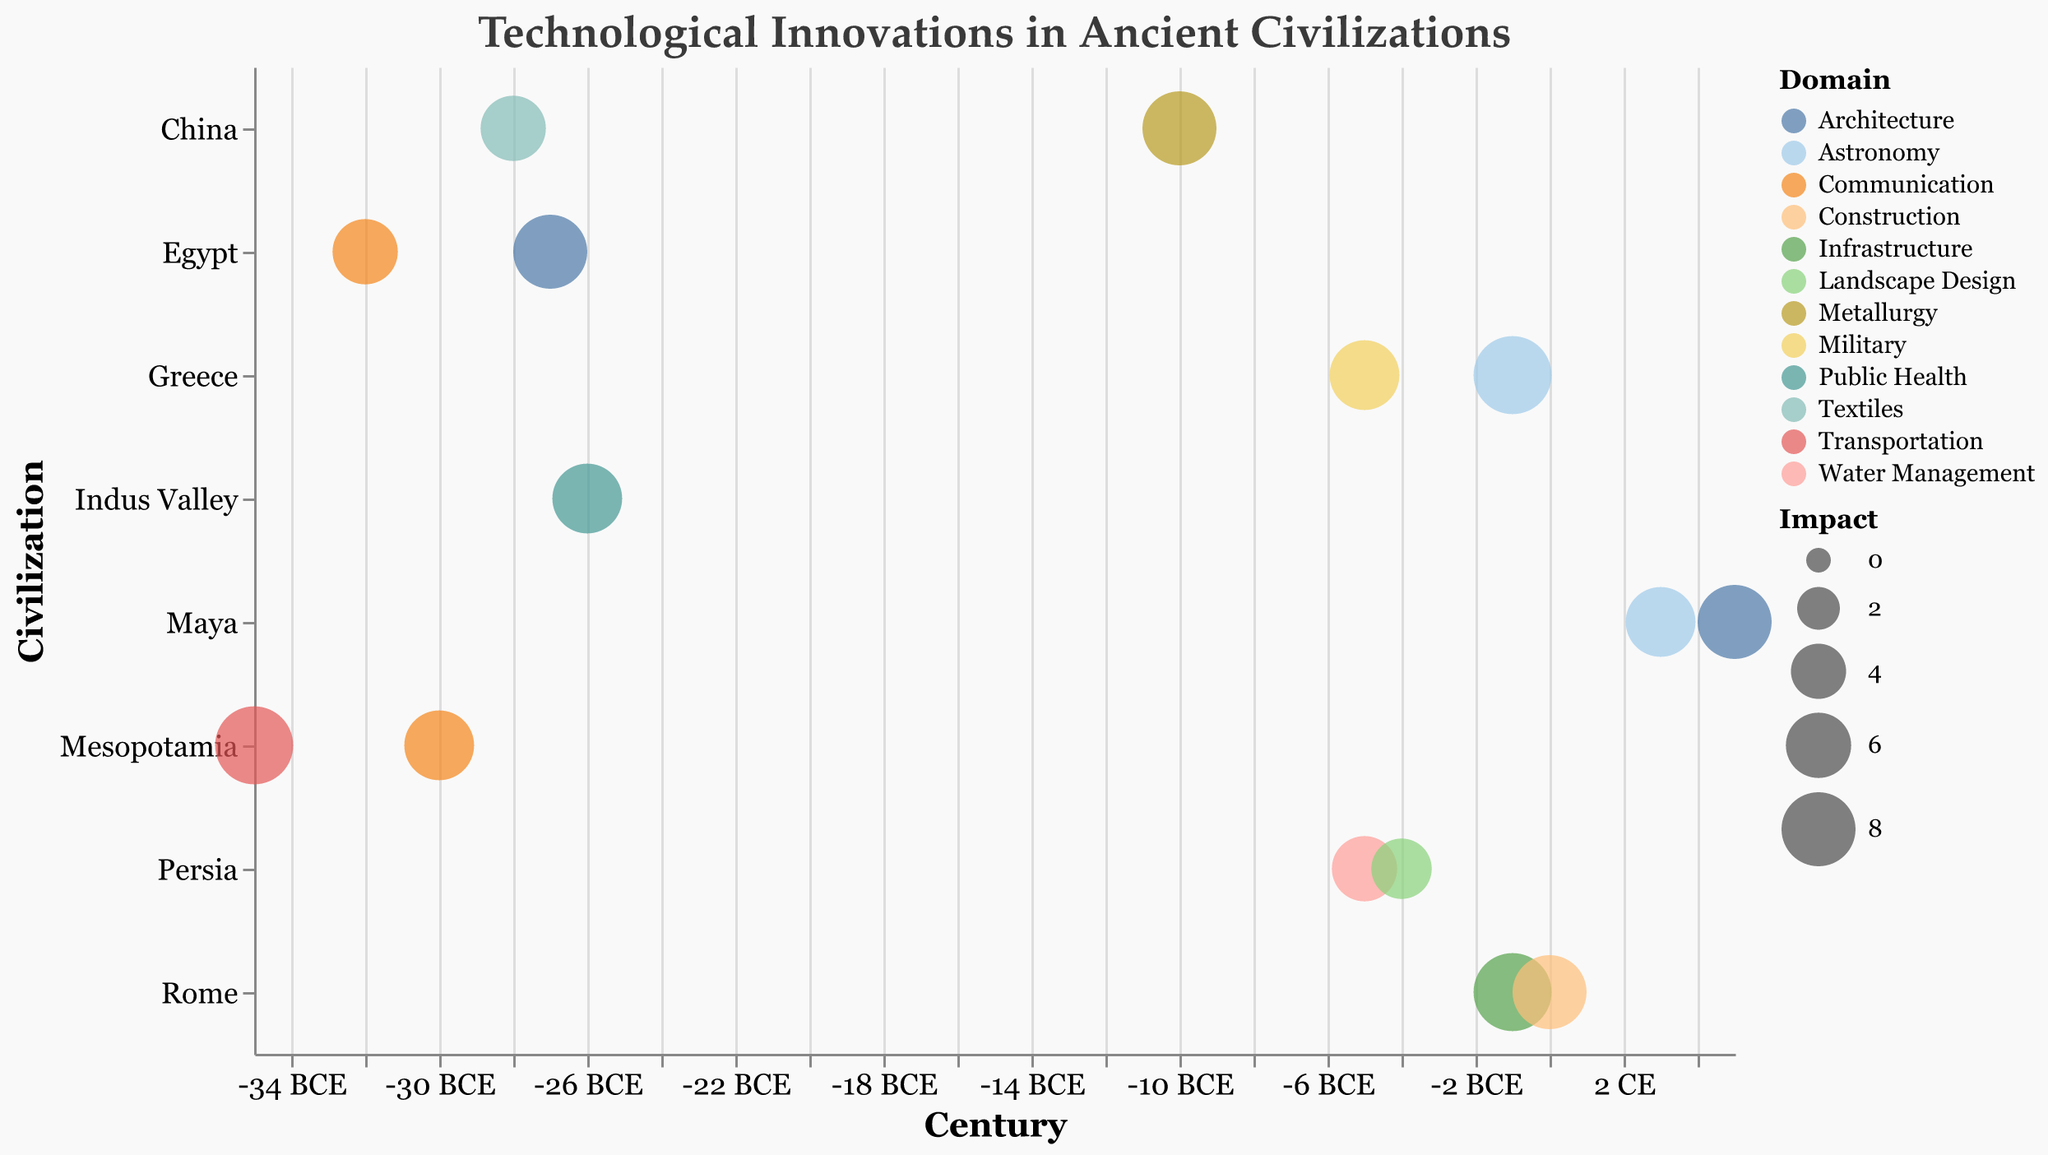What's the title of the chart? The title of the chart is displayed at the top and reads "Technological Innovations in Ancient Civilizations."
Answer: Technological Innovations in Ancient Civilizations How many innovations are depicted for the civilization of Greece? By counting the bubbles aligned with Greece on the y-axis, we see there are two innovations: "Antikythera Mechanism" and "Phalanx Warfare."
Answer: 2 Which innovation from Mesopotamia has the highest impact? By looking at the size of the bubbles for Mesopotamia, we find that the innovation "Wheel" has the largest bubble, indicating the highest impact of 9.
Answer: Wheel How does the impact of China's "Silk Weaving" compare to its "Cast Iron"? "Silk Weaving" has an impact of 6, while "Cast Iron" has an impact of 8. Therefore, "Cast Iron" has a higher impact than "Silk Weaving."
Answer: Cast Iron has higher impact Between which centuries do we see the most innovations in this chart? Observing the distribution of bubbles along the x-axis, most innovations appear between the 0 and -35 centuries. This indicates a rich period of technological advancement before the common era.
Answer: -35 to 0 centuries What is the century range of Persian innovations? Counting the bubbles belonging to Persia, the innovations "Qanat System" and "Paradise Gardens" span between -5 and -4 centuries.
Answer: -5 to -4 centuries Which civilization introduced an innovation in the domain of "Textiles"? Checking the color legends and the bubbles, we find that China introduced "Silk Weaving" in the textiles domain.
Answer: China What's the average impact of innovations in the domain of Astronomy? First, identify innovations in Astronomy: "Antikythera Mechanism" (Impact 9) and "Calendar Systems" (Impact 7). Average impact = (9 + 7) / 2 = 8.
Answer: 8 How many innovations in infrastructure are depicted, and which civilizations introduced them? There is one innovation in the infrastructure domain: "Aqueducts" introduced by Rome.
Answer: 1, Rome Which has more innovations: Mesopotamia or China, and by how many? Mesopotamia has two innovations ("Cuneiform Writing" and "Wheel"), while China has two ("Silk Weaving" and "Cast Iron"). Hence, both have an equal number of innovations.
Answer: Equal number (2) 